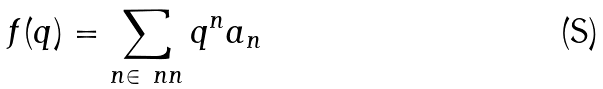Convert formula to latex. <formula><loc_0><loc_0><loc_500><loc_500>f ( q ) = \sum _ { n \in \ n n } q ^ { n } a _ { n }</formula> 